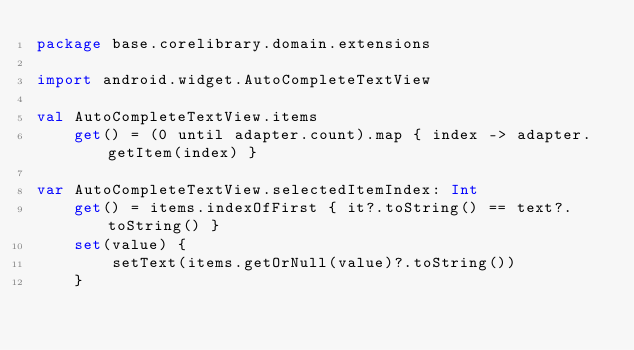<code> <loc_0><loc_0><loc_500><loc_500><_Kotlin_>package base.corelibrary.domain.extensions

import android.widget.AutoCompleteTextView

val AutoCompleteTextView.items
    get() = (0 until adapter.count).map { index -> adapter.getItem(index) }

var AutoCompleteTextView.selectedItemIndex: Int
    get() = items.indexOfFirst { it?.toString() == text?.toString() }
    set(value) {
        setText(items.getOrNull(value)?.toString())
    }</code> 